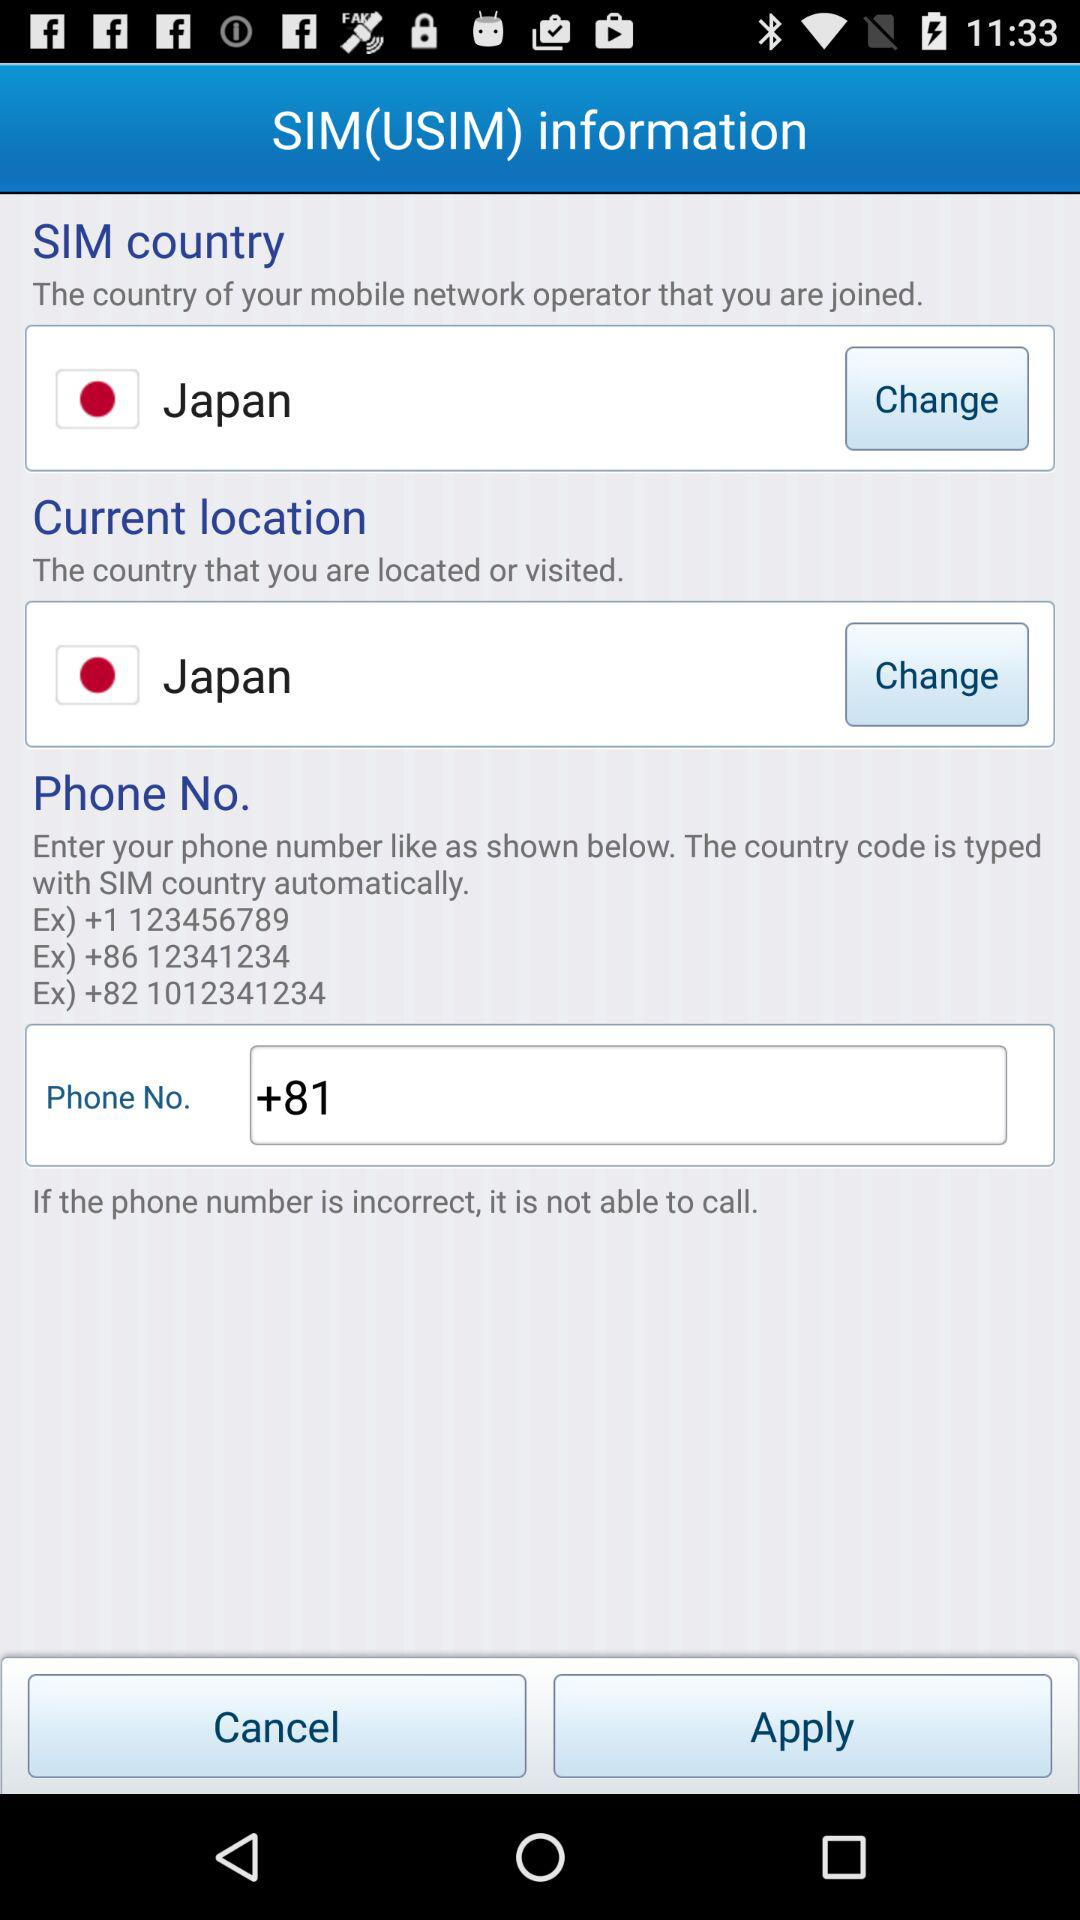What is the selected SIM country? The selected SIM country is Japan. 